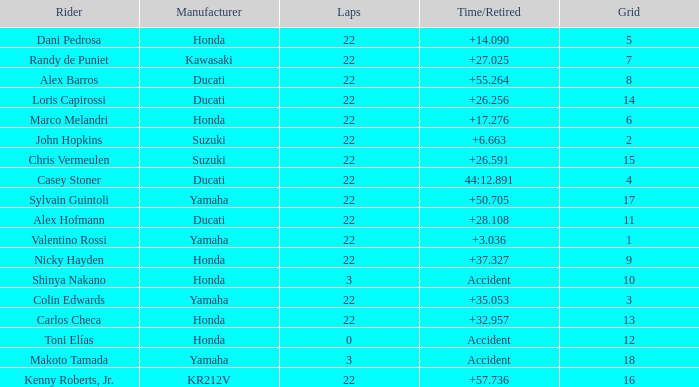What was the average amount of laps for competitors with a grid that was more than 11 and a Time/Retired of +28.108? None. 